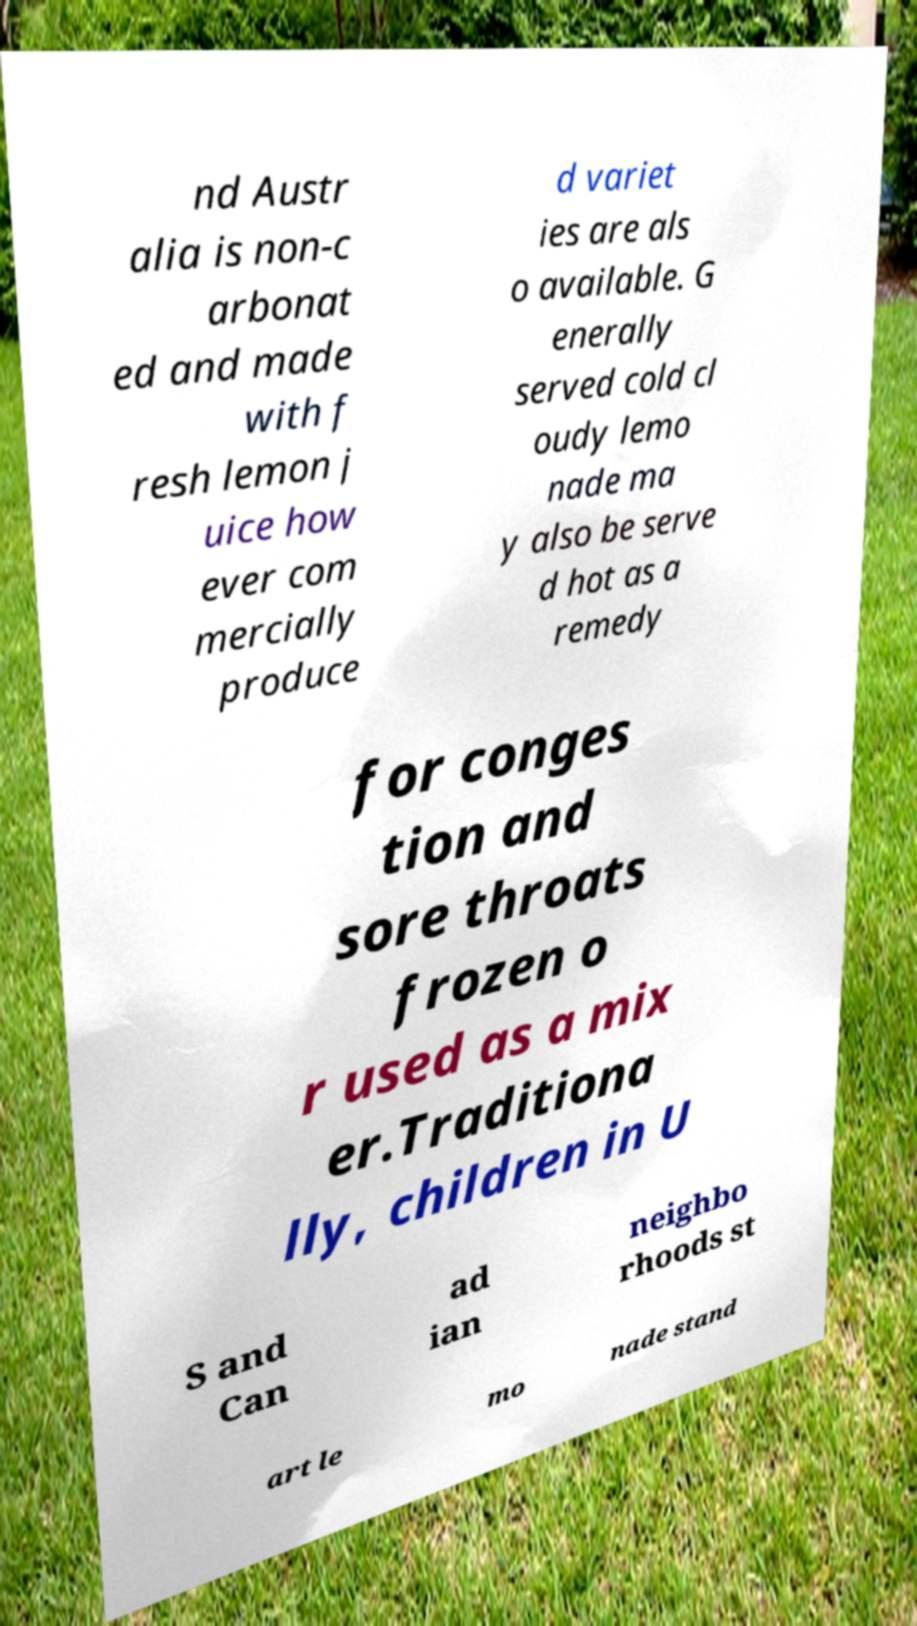Can you accurately transcribe the text from the provided image for me? nd Austr alia is non-c arbonat ed and made with f resh lemon j uice how ever com mercially produce d variet ies are als o available. G enerally served cold cl oudy lemo nade ma y also be serve d hot as a remedy for conges tion and sore throats frozen o r used as a mix er.Traditiona lly, children in U S and Can ad ian neighbo rhoods st art le mo nade stand 